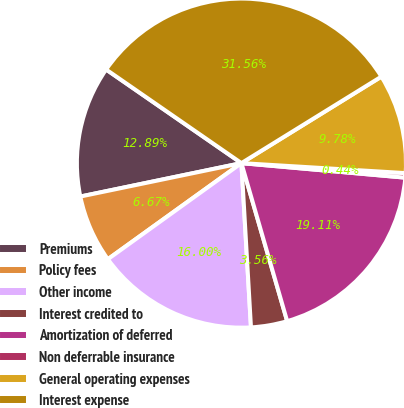Convert chart. <chart><loc_0><loc_0><loc_500><loc_500><pie_chart><fcel>Premiums<fcel>Policy fees<fcel>Other income<fcel>Interest credited to<fcel>Amortization of deferred<fcel>Non deferrable insurance<fcel>General operating expenses<fcel>Interest expense<nl><fcel>12.89%<fcel>6.67%<fcel>16.0%<fcel>3.56%<fcel>19.11%<fcel>0.44%<fcel>9.78%<fcel>31.56%<nl></chart> 